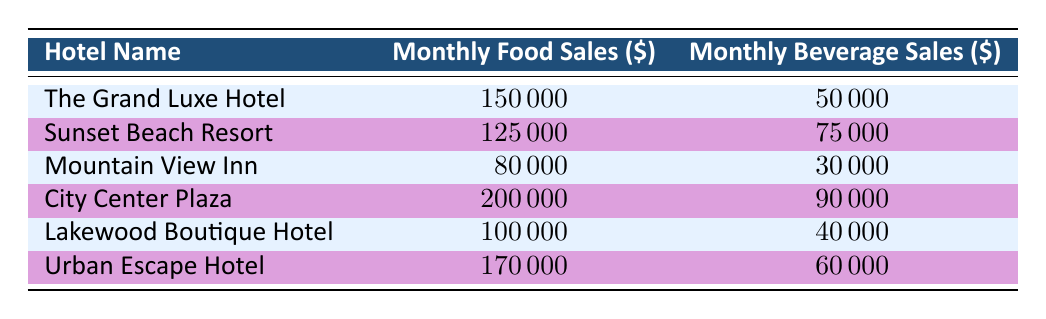What is the monthly food sales of City Center Plaza? The table shows that City Center Plaza's monthly food sales are listed directly, which is 200,000 dollars.
Answer: 200000 Which hotel has the highest beverage sales? In the table, we can compare the monthly beverage sales. City Center Plaza has the highest at 90,000 dollars.
Answer: City Center Plaza What is the total monthly food sales for all hotels combined? To find the total, we add the food sales of all hotels: 150000 + 125000 + 80000 + 200000 + 100000 + 170000 = 925000.
Answer: 925000 Is the monthly beverage sales for Lakewood Boutique Hotel greater than Urban Escape Hotel? Looking at the table, Lakewood's beverage sales are 40,000 dollars, while Urban Escape's are 60,000 dollars. Therefore, it's false.
Answer: No What is the average monthly food sales from all the hotels? First, sum the monthly food sales: (150000 + 125000 + 80000 + 200000 + 100000 + 170000) = 925000. There are 6 hotels, so the average is 925000 / 6 = 154166.67.
Answer: 154166.67 Which hotel has the lowest combined sales from food and beverage? To find the hotel with the lowest combined sales, we calculate each hotel's total sales: The Grand Luxe Hotel (200000), Sunset Beach Resort (200000), Mountain View Inn (110000), City Center Plaza (290000), Lakewood Boutique Hotel (140000), Urban Escape Hotel (230000). Mountain View Inn has the lowest at 110000.
Answer: Mountain View Inn Is the total monthly beverage sales for all hotels greater than 400,000 dollars? Calculating the total beverage sales: 50000 + 75000 + 30000 + 90000 + 40000 + 60000 = 360000. Since 360000 is less than 400000, the answer is no.
Answer: No What is the difference in food sales between The Grand Luxe Hotel and Mountain View Inn? The food sales for The Grand Luxe Hotel is 150,000 dollars, and for Mountain View Inn, it is 80,000 dollars. The difference is 150000 - 80000 = 70000.
Answer: 70000 